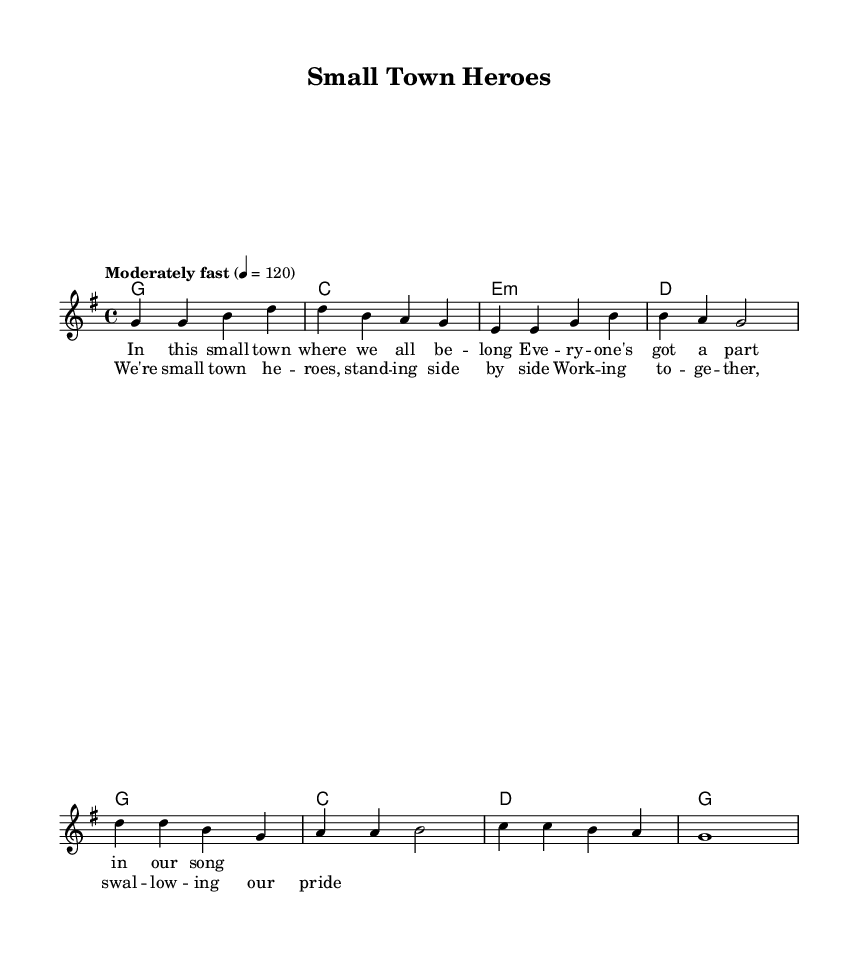What is the key signature of this music? The key signature is indicated at the beginning of the sheet music, and it shows one sharp, which corresponds to G major.
Answer: G major What is the time signature? The time signature is located at the beginning of the sheet music, indicating how many beats are in each measure and which note value gets the beat. The sheet indicates 4/4, meaning there are four beats per measure.
Answer: 4/4 What is the tempo marking for this piece? The tempo marking is written above the staff, indicating the speed at which the piece should be played. It states "Moderately fast" at a beat of 120.
Answer: Moderately fast How many measures are in the verse? To find the number of measures in the verse, we need to count the vertical lines that separate the measures in the section labeled as "Verse." There are four measures in the verse.
Answer: Four What is the lyrical theme of the chorus? The lyrical theme can be inferred from the words written for the chorus section, which emphasize teamwork and community as they mention "small town heroes" and "working together."
Answer: Teamwork How many chords are used in the chorus? To determine the number of chords in the chorus, we count the chord symbols above the lyrics. There are four unique chord symbols presented in the chorus.
Answer: Four Which musical genre does this piece belong to? The genre can be identified by the style and characteristics present in the sheet music as well as the lyrical themes. The song is classified as Country Rock, combining traditional country themes with rock elements.
Answer: Country Rock 